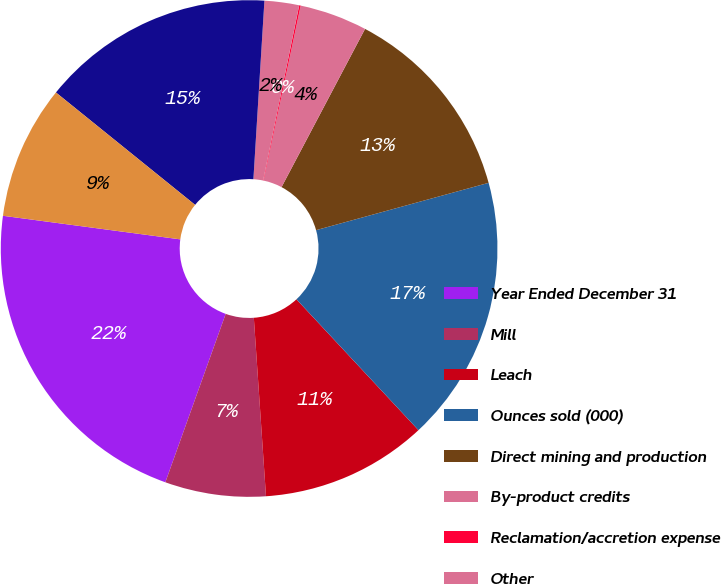Convert chart to OTSL. <chart><loc_0><loc_0><loc_500><loc_500><pie_chart><fcel>Year Ended December 31<fcel>Mill<fcel>Leach<fcel>Ounces sold (000)<fcel>Direct mining and production<fcel>By-product credits<fcel>Reclamation/accretion expense<fcel>Other<fcel>Costs applicable to sales<fcel>Depreciation depletion and<nl><fcel>21.63%<fcel>6.56%<fcel>10.86%<fcel>17.32%<fcel>13.01%<fcel>4.4%<fcel>0.1%<fcel>2.25%<fcel>15.17%<fcel>8.71%<nl></chart> 